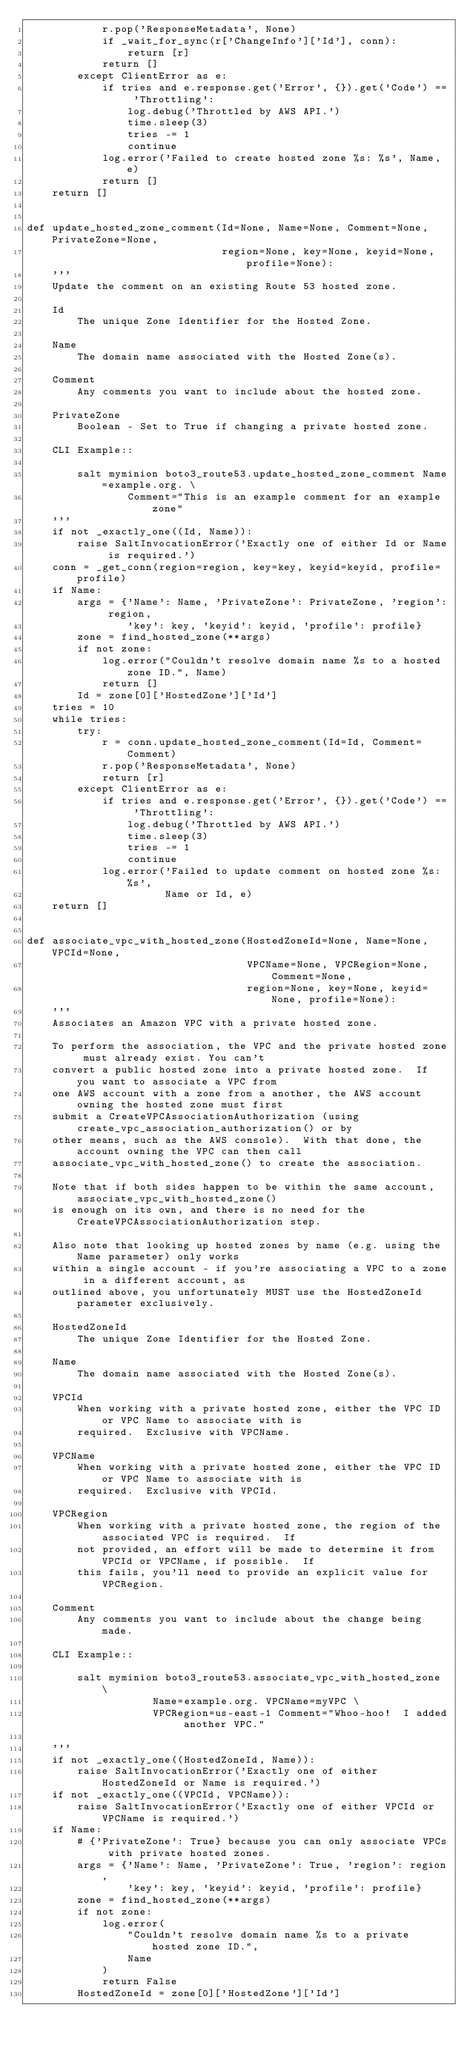Convert code to text. <code><loc_0><loc_0><loc_500><loc_500><_Python_>            r.pop('ResponseMetadata', None)
            if _wait_for_sync(r['ChangeInfo']['Id'], conn):
                return [r]
            return []
        except ClientError as e:
            if tries and e.response.get('Error', {}).get('Code') == 'Throttling':
                log.debug('Throttled by AWS API.')
                time.sleep(3)
                tries -= 1
                continue
            log.error('Failed to create hosted zone %s: %s', Name, e)
            return []
    return []


def update_hosted_zone_comment(Id=None, Name=None, Comment=None, PrivateZone=None,
                               region=None, key=None, keyid=None, profile=None):
    '''
    Update the comment on an existing Route 53 hosted zone.

    Id
        The unique Zone Identifier for the Hosted Zone.

    Name
        The domain name associated with the Hosted Zone(s).

    Comment
        Any comments you want to include about the hosted zone.

    PrivateZone
        Boolean - Set to True if changing a private hosted zone.

    CLI Example::

        salt myminion boto3_route53.update_hosted_zone_comment Name=example.org. \
                Comment="This is an example comment for an example zone"
    '''
    if not _exactly_one((Id, Name)):
        raise SaltInvocationError('Exactly one of either Id or Name is required.')
    conn = _get_conn(region=region, key=key, keyid=keyid, profile=profile)
    if Name:
        args = {'Name': Name, 'PrivateZone': PrivateZone, 'region': region,
                'key': key, 'keyid': keyid, 'profile': profile}
        zone = find_hosted_zone(**args)
        if not zone:
            log.error("Couldn't resolve domain name %s to a hosted zone ID.", Name)
            return []
        Id = zone[0]['HostedZone']['Id']
    tries = 10
    while tries:
        try:
            r = conn.update_hosted_zone_comment(Id=Id, Comment=Comment)
            r.pop('ResponseMetadata', None)
            return [r]
        except ClientError as e:
            if tries and e.response.get('Error', {}).get('Code') == 'Throttling':
                log.debug('Throttled by AWS API.')
                time.sleep(3)
                tries -= 1
                continue
            log.error('Failed to update comment on hosted zone %s: %s',
                      Name or Id, e)
    return []


def associate_vpc_with_hosted_zone(HostedZoneId=None, Name=None, VPCId=None,
                                   VPCName=None, VPCRegion=None, Comment=None,
                                   region=None, key=None, keyid=None, profile=None):
    '''
    Associates an Amazon VPC with a private hosted zone.

    To perform the association, the VPC and the private hosted zone must already exist. You can't
    convert a public hosted zone into a private hosted zone.  If you want to associate a VPC from
    one AWS account with a zone from a another, the AWS account owning the hosted zone must first
    submit a CreateVPCAssociationAuthorization (using create_vpc_association_authorization() or by
    other means, such as the AWS console).  With that done, the account owning the VPC can then call
    associate_vpc_with_hosted_zone() to create the association.

    Note that if both sides happen to be within the same account, associate_vpc_with_hosted_zone()
    is enough on its own, and there is no need for the CreateVPCAssociationAuthorization step.

    Also note that looking up hosted zones by name (e.g. using the Name parameter) only works
    within a single account - if you're associating a VPC to a zone in a different account, as
    outlined above, you unfortunately MUST use the HostedZoneId parameter exclusively.

    HostedZoneId
        The unique Zone Identifier for the Hosted Zone.

    Name
        The domain name associated with the Hosted Zone(s).

    VPCId
        When working with a private hosted zone, either the VPC ID or VPC Name to associate with is
        required.  Exclusive with VPCName.

    VPCName
        When working with a private hosted zone, either the VPC ID or VPC Name to associate with is
        required.  Exclusive with VPCId.

    VPCRegion
        When working with a private hosted zone, the region of the associated VPC is required.  If
        not provided, an effort will be made to determine it from VPCId or VPCName, if possible.  If
        this fails, you'll need to provide an explicit value for VPCRegion.

    Comment
        Any comments you want to include about the change being made.

    CLI Example::

        salt myminion boto3_route53.associate_vpc_with_hosted_zone \
                    Name=example.org. VPCName=myVPC \
                    VPCRegion=us-east-1 Comment="Whoo-hoo!  I added another VPC."

    '''
    if not _exactly_one((HostedZoneId, Name)):
        raise SaltInvocationError('Exactly one of either HostedZoneId or Name is required.')
    if not _exactly_one((VPCId, VPCName)):
        raise SaltInvocationError('Exactly one of either VPCId or VPCName is required.')
    if Name:
        # {'PrivateZone': True} because you can only associate VPCs with private hosted zones.
        args = {'Name': Name, 'PrivateZone': True, 'region': region,
                'key': key, 'keyid': keyid, 'profile': profile}
        zone = find_hosted_zone(**args)
        if not zone:
            log.error(
                "Couldn't resolve domain name %s to a private hosted zone ID.",
                Name
            )
            return False
        HostedZoneId = zone[0]['HostedZone']['Id']</code> 